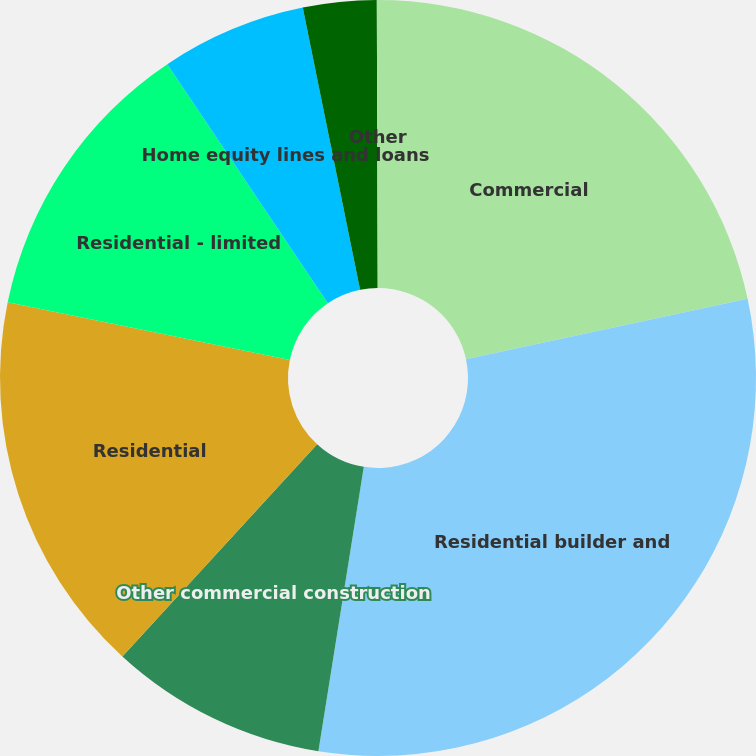Convert chart to OTSL. <chart><loc_0><loc_0><loc_500><loc_500><pie_chart><fcel>Commercial<fcel>Residential builder and<fcel>Other commercial construction<fcel>Residential<fcel>Residential - limited<fcel>Home equity lines and loans<fcel>Automobile<fcel>Other<nl><fcel>21.64%<fcel>30.88%<fcel>9.3%<fcel>16.39%<fcel>12.38%<fcel>6.22%<fcel>3.14%<fcel>0.05%<nl></chart> 